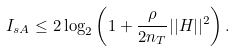<formula> <loc_0><loc_0><loc_500><loc_500>I _ { s A } \leq 2 \log _ { 2 } \left ( 1 + \frac { \rho } { 2 n _ { T } } | | H | | ^ { 2 } \right ) .</formula> 